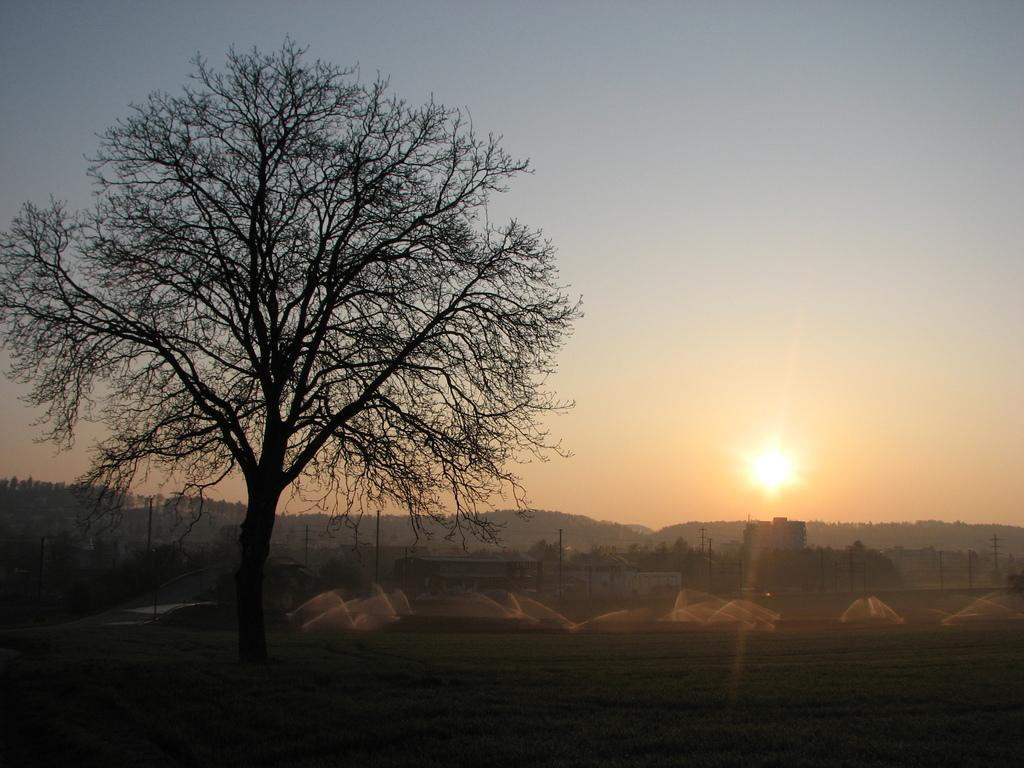What is located on the left side of the image? There is a tree on the left side of the image. What can be seen at the bottom of the image? There are sprinklers at the bottom of the image. What is visible in the background of the image? There are poles and a hill in the background of the image, as well as the sky. Can you describe the sun in the image? Yes, there is a sun in the center of the image. What is the aftermath of the sea attack in the image? There is no sea or attack present in the image; it features a tree, sprinklers, poles, a hill, and a sun. 